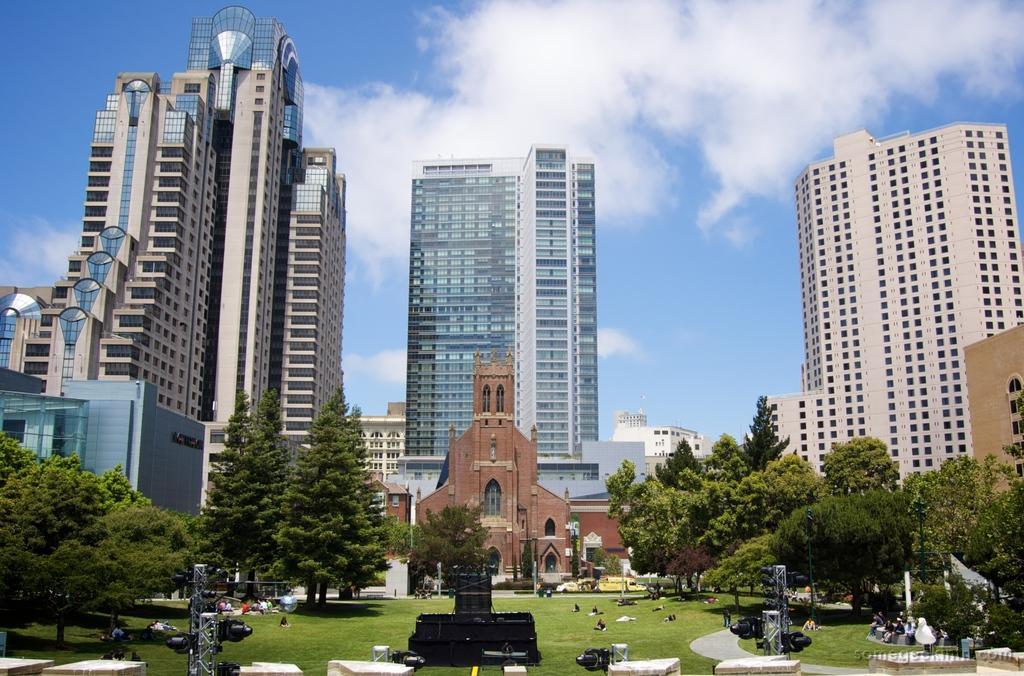Can you describe this image briefly? In this image I can see buildings and trees and persons visible on ground ,at the top there is the sky. 